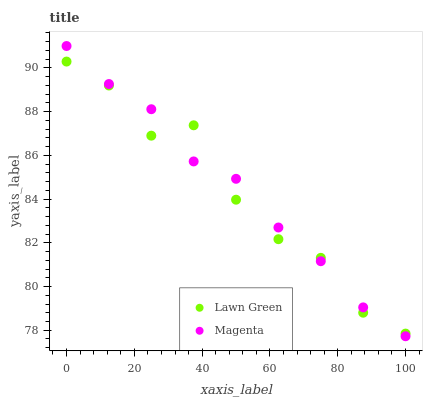Does Lawn Green have the minimum area under the curve?
Answer yes or no. Yes. Does Magenta have the maximum area under the curve?
Answer yes or no. Yes. Does Magenta have the minimum area under the curve?
Answer yes or no. No. Is Magenta the smoothest?
Answer yes or no. Yes. Is Lawn Green the roughest?
Answer yes or no. Yes. Is Magenta the roughest?
Answer yes or no. No. Does Magenta have the lowest value?
Answer yes or no. Yes. Does Magenta have the highest value?
Answer yes or no. Yes. Does Magenta intersect Lawn Green?
Answer yes or no. Yes. Is Magenta less than Lawn Green?
Answer yes or no. No. Is Magenta greater than Lawn Green?
Answer yes or no. No. 